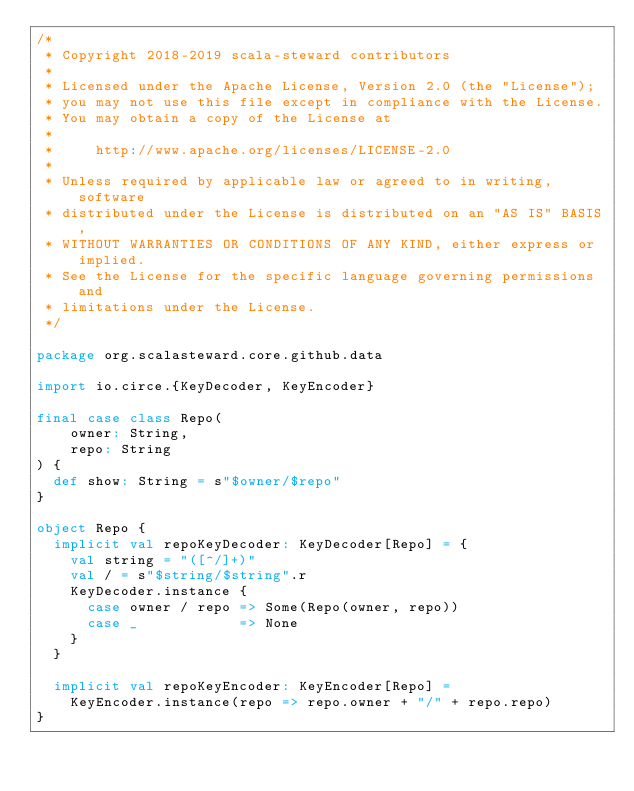Convert code to text. <code><loc_0><loc_0><loc_500><loc_500><_Scala_>/*
 * Copyright 2018-2019 scala-steward contributors
 *
 * Licensed under the Apache License, Version 2.0 (the "License");
 * you may not use this file except in compliance with the License.
 * You may obtain a copy of the License at
 *
 *     http://www.apache.org/licenses/LICENSE-2.0
 *
 * Unless required by applicable law or agreed to in writing, software
 * distributed under the License is distributed on an "AS IS" BASIS,
 * WITHOUT WARRANTIES OR CONDITIONS OF ANY KIND, either express or implied.
 * See the License for the specific language governing permissions and
 * limitations under the License.
 */

package org.scalasteward.core.github.data

import io.circe.{KeyDecoder, KeyEncoder}

final case class Repo(
    owner: String,
    repo: String
) {
  def show: String = s"$owner/$repo"
}

object Repo {
  implicit val repoKeyDecoder: KeyDecoder[Repo] = {
    val string = "([^/]+)"
    val / = s"$string/$string".r
    KeyDecoder.instance {
      case owner / repo => Some(Repo(owner, repo))
      case _            => None
    }
  }

  implicit val repoKeyEncoder: KeyEncoder[Repo] =
    KeyEncoder.instance(repo => repo.owner + "/" + repo.repo)
}
</code> 